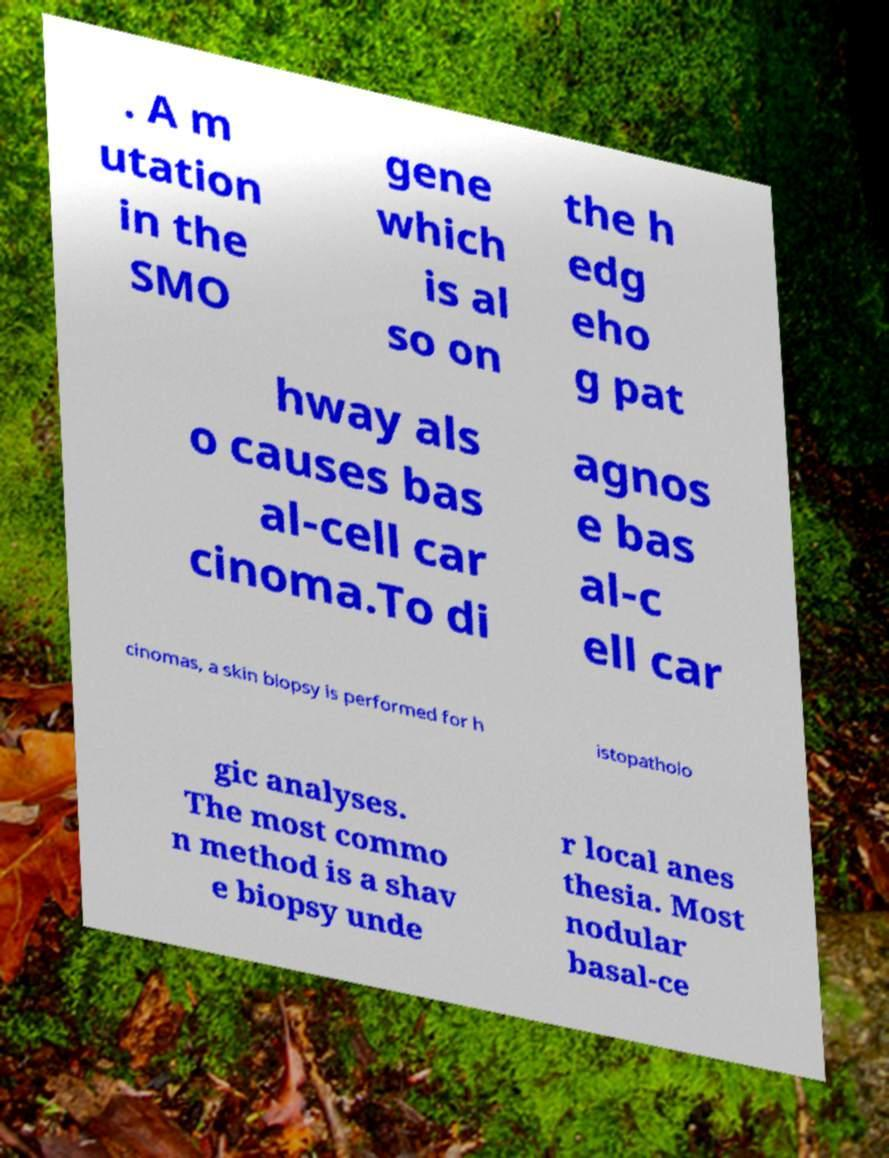What messages or text are displayed in this image? I need them in a readable, typed format. . A m utation in the SMO gene which is al so on the h edg eho g pat hway als o causes bas al-cell car cinoma.To di agnos e bas al-c ell car cinomas, a skin biopsy is performed for h istopatholo gic analyses. The most commo n method is a shav e biopsy unde r local anes thesia. Most nodular basal-ce 